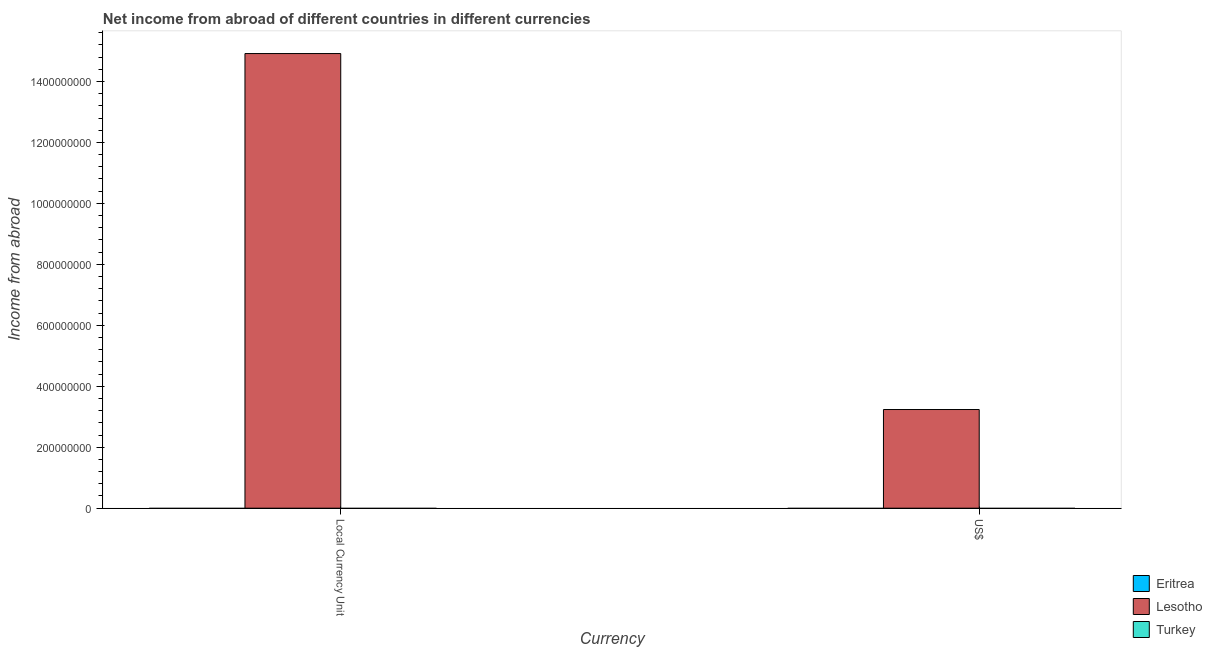Are the number of bars per tick equal to the number of legend labels?
Offer a very short reply. No. Are the number of bars on each tick of the X-axis equal?
Offer a terse response. Yes. How many bars are there on the 2nd tick from the left?
Ensure brevity in your answer.  1. What is the label of the 1st group of bars from the left?
Make the answer very short. Local Currency Unit. What is the income from abroad in constant 2005 us$ in Eritrea?
Provide a succinct answer. 0. Across all countries, what is the maximum income from abroad in constant 2005 us$?
Your response must be concise. 1.49e+09. In which country was the income from abroad in us$ maximum?
Offer a terse response. Lesotho. What is the total income from abroad in us$ in the graph?
Make the answer very short. 3.24e+08. What is the difference between the income from abroad in us$ in Eritrea and the income from abroad in constant 2005 us$ in Lesotho?
Your answer should be very brief. -1.49e+09. What is the average income from abroad in us$ per country?
Make the answer very short. 1.08e+08. Does the graph contain any zero values?
Offer a very short reply. Yes. Where does the legend appear in the graph?
Give a very brief answer. Bottom right. How many legend labels are there?
Provide a succinct answer. 3. What is the title of the graph?
Your answer should be very brief. Net income from abroad of different countries in different currencies. What is the label or title of the X-axis?
Your answer should be compact. Currency. What is the label or title of the Y-axis?
Provide a succinct answer. Income from abroad. What is the Income from abroad of Lesotho in Local Currency Unit?
Your answer should be very brief. 1.49e+09. What is the Income from abroad of Lesotho in US$?
Give a very brief answer. 3.24e+08. What is the Income from abroad of Turkey in US$?
Provide a succinct answer. 0. Across all Currency, what is the maximum Income from abroad in Lesotho?
Keep it short and to the point. 1.49e+09. Across all Currency, what is the minimum Income from abroad of Lesotho?
Offer a terse response. 3.24e+08. What is the total Income from abroad in Eritrea in the graph?
Offer a very short reply. 0. What is the total Income from abroad of Lesotho in the graph?
Ensure brevity in your answer.  1.82e+09. What is the difference between the Income from abroad in Lesotho in Local Currency Unit and that in US$?
Provide a succinct answer. 1.17e+09. What is the average Income from abroad in Eritrea per Currency?
Provide a succinct answer. 0. What is the average Income from abroad of Lesotho per Currency?
Keep it short and to the point. 9.08e+08. What is the average Income from abroad in Turkey per Currency?
Your answer should be very brief. 0. What is the ratio of the Income from abroad of Lesotho in Local Currency Unit to that in US$?
Provide a short and direct response. 4.61. What is the difference between the highest and the second highest Income from abroad in Lesotho?
Keep it short and to the point. 1.17e+09. What is the difference between the highest and the lowest Income from abroad of Lesotho?
Provide a short and direct response. 1.17e+09. 